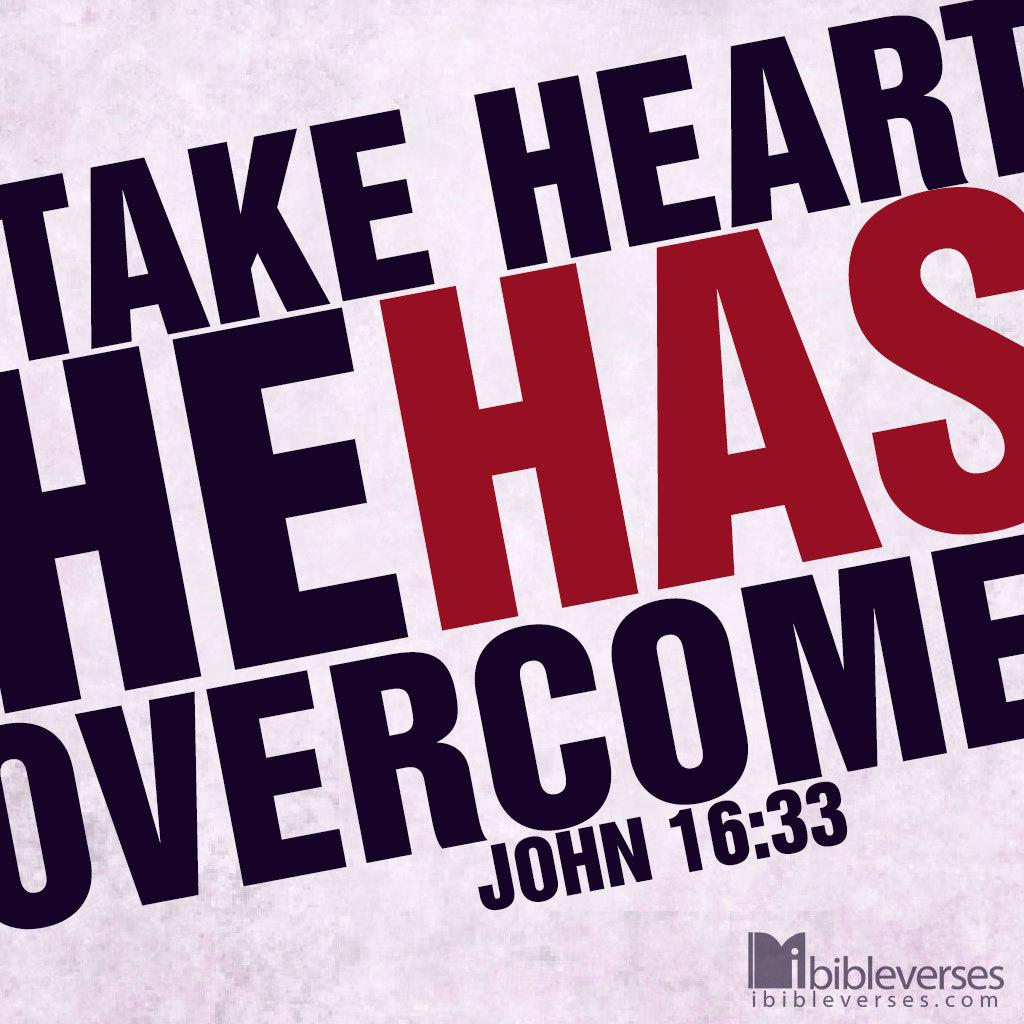<image>
Give a short and clear explanation of the subsequent image. Saying that says "Take Heart He Has Overcome". 